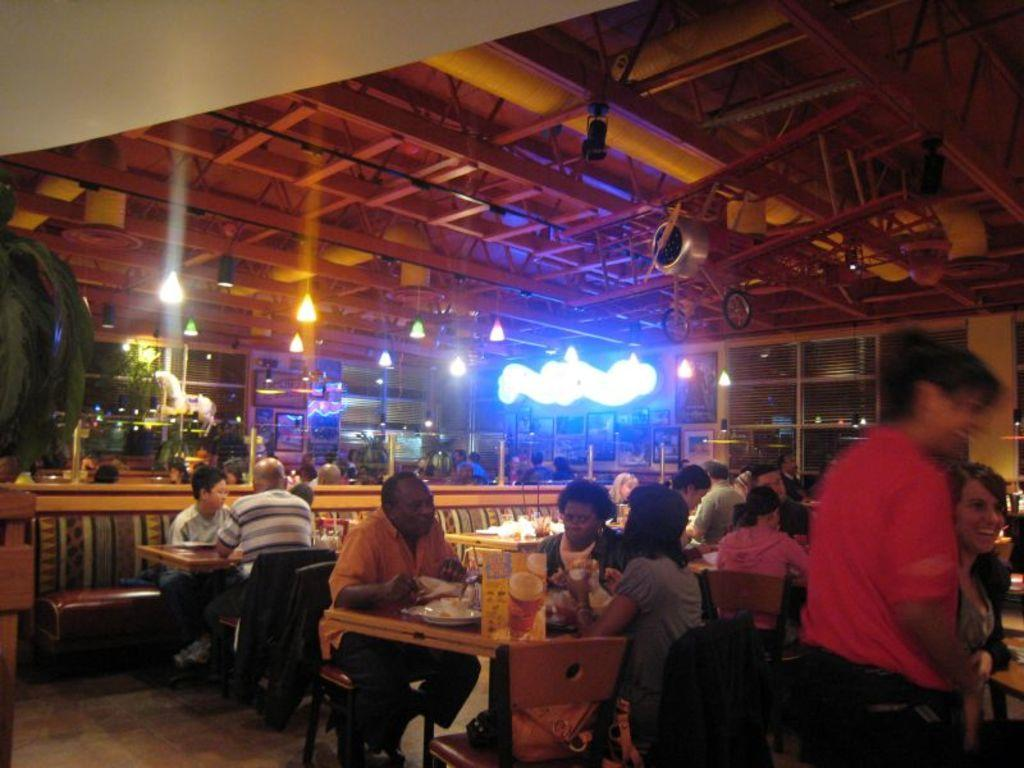What is attached to the rooftop in the image? Lights are attached to the rooftop. What are most people doing in the image? Most people are sitting on chairs. What can be found on the table in the image? There are items on a table. Can you describe the position of one person in the image? There is a person standing. What type of fowl can be seen interacting with the person standing in the image? There is no fowl present in the image; only people and lights are visible. Can you describe the woman's outfit in the image? There is no woman present in the image; only people are visible, but their gender and outfits cannot be determined from the image. 